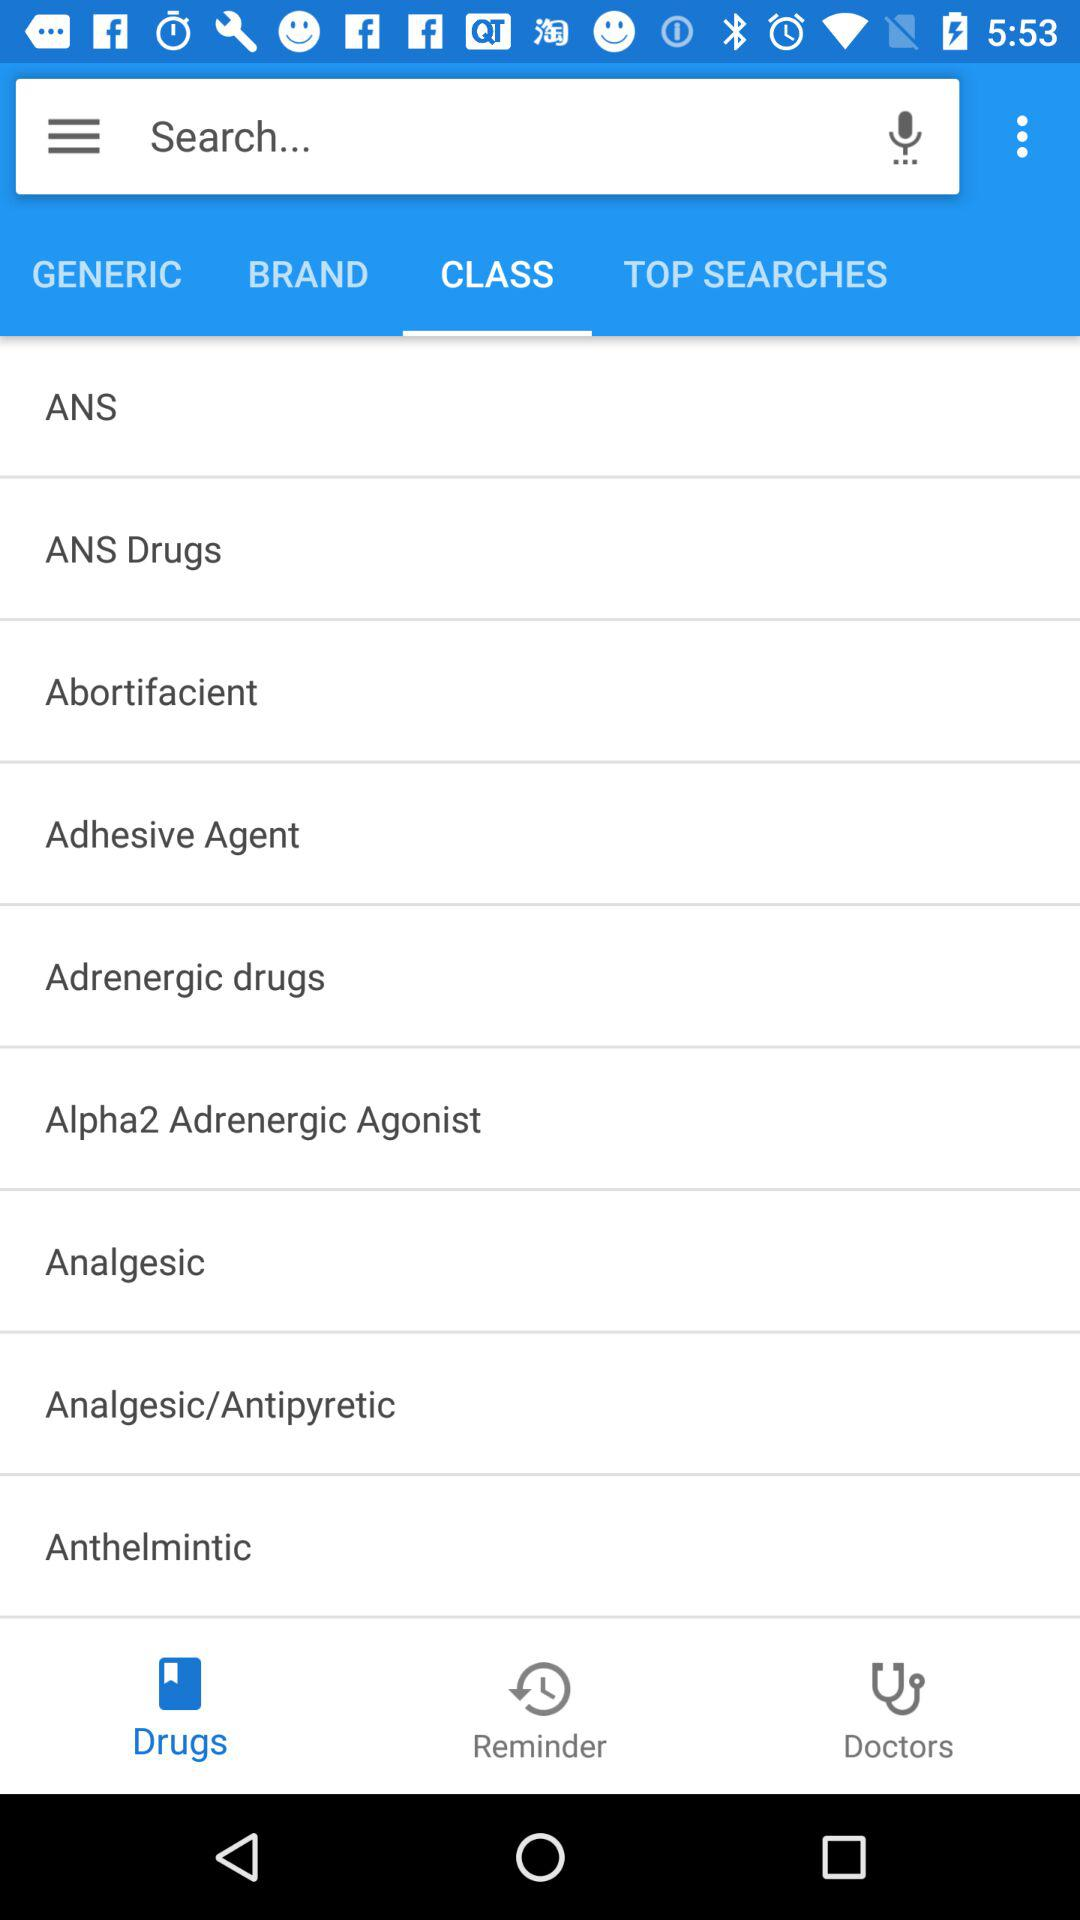What is the selected tab? The selected tab is "CLASS". 